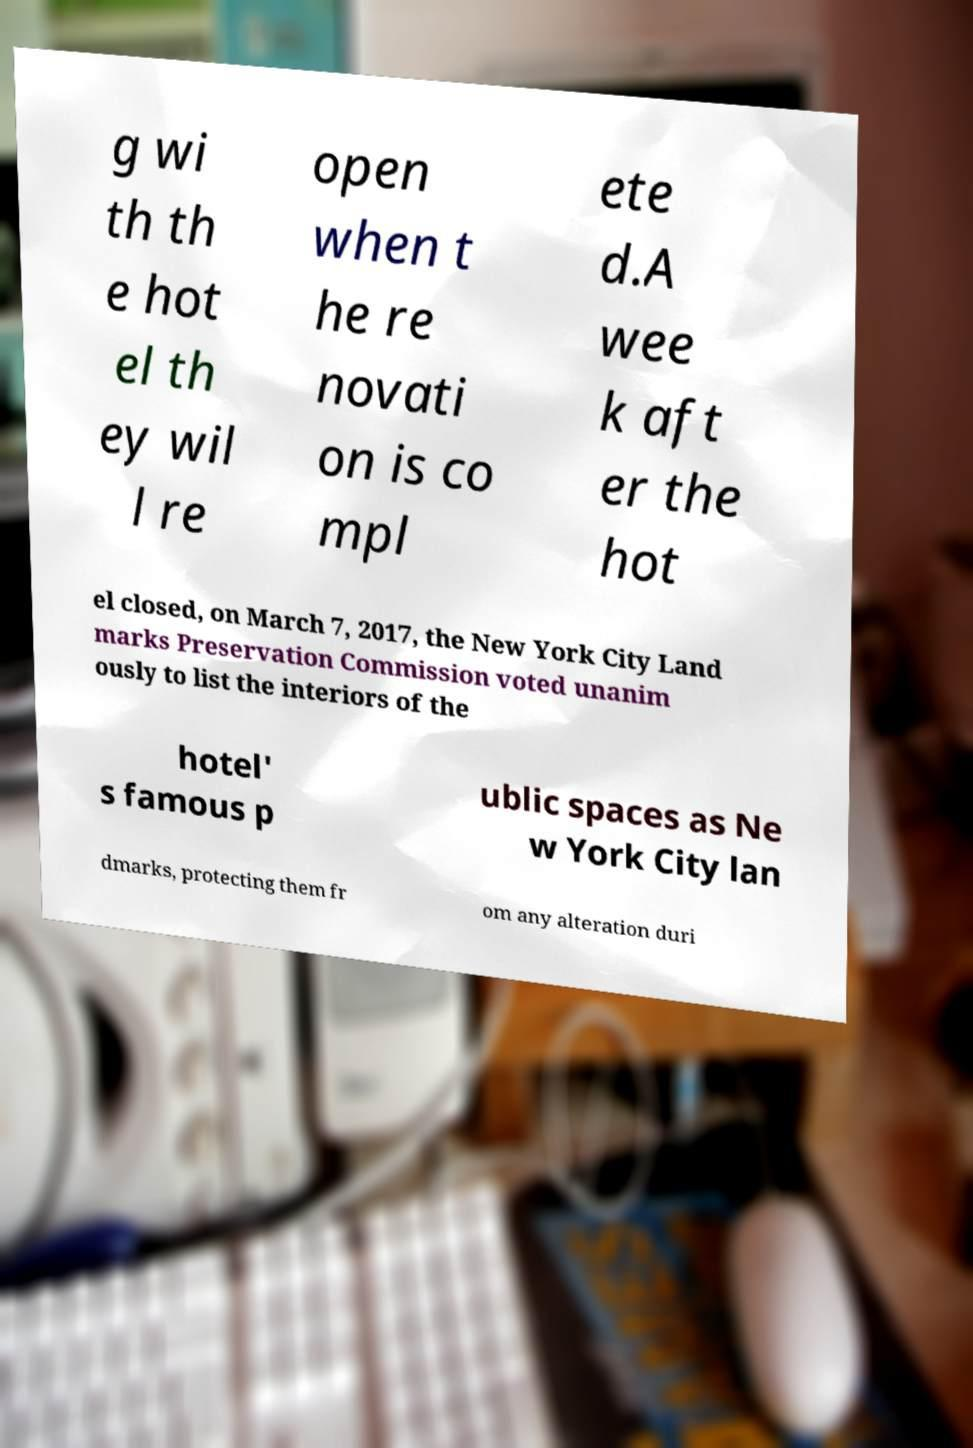Could you extract and type out the text from this image? g wi th th e hot el th ey wil l re open when t he re novati on is co mpl ete d.A wee k aft er the hot el closed, on March 7, 2017, the New York City Land marks Preservation Commission voted unanim ously to list the interiors of the hotel' s famous p ublic spaces as Ne w York City lan dmarks, protecting them fr om any alteration duri 